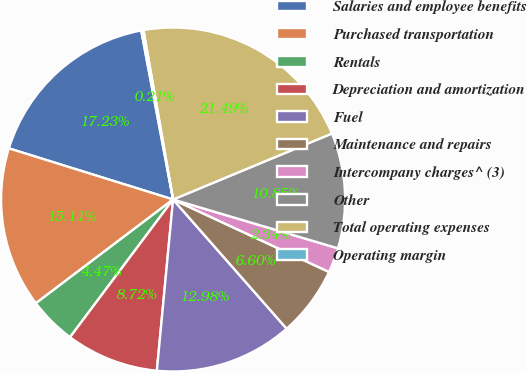<chart> <loc_0><loc_0><loc_500><loc_500><pie_chart><fcel>Salaries and employee benefits<fcel>Purchased transportation<fcel>Rentals<fcel>Depreciation and amortization<fcel>Fuel<fcel>Maintenance and repairs<fcel>Intercompany charges^ (3)<fcel>Other<fcel>Total operating expenses<fcel>Operating margin<nl><fcel>17.23%<fcel>15.11%<fcel>4.47%<fcel>8.72%<fcel>12.98%<fcel>6.6%<fcel>2.34%<fcel>10.85%<fcel>21.49%<fcel>0.21%<nl></chart> 